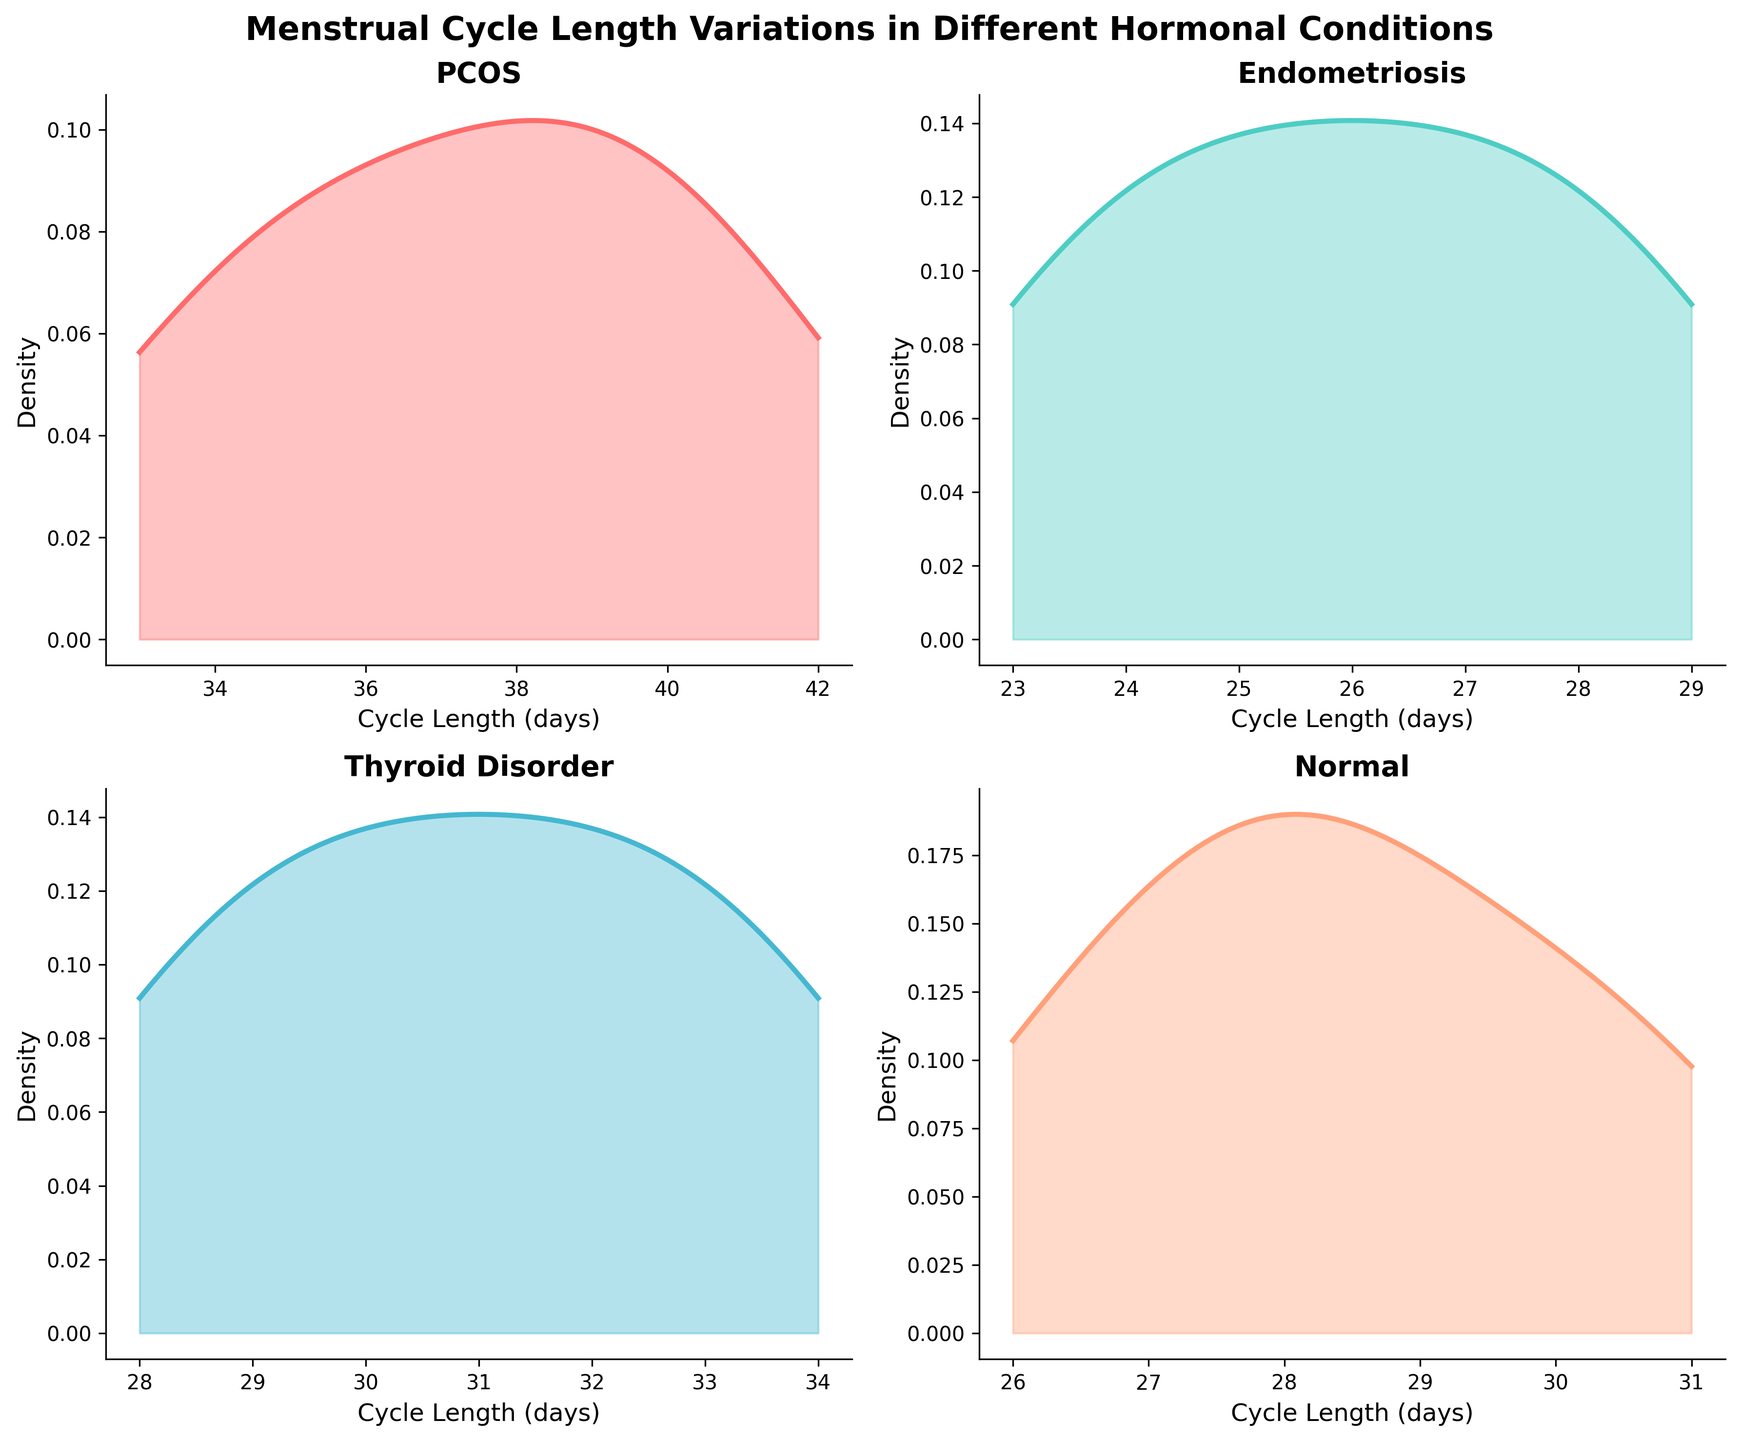How many conditions are presented in the figure? The figure shows four different subplots, each with a unique condition. They are PCOS, Endometriosis, Thyroid Disorder, and Normal, as indicated by the subplot titles.
Answer: 4 Which condition has the highest variability in menstrual cycle length? To determine the condition with the highest variability, observe the spread of the peaks in each subplot. The PCOS subplot shows a wider spread than the other conditions, indicating higher variability in cycle length.
Answer: PCOS What is the range of cycle lengths for the condition with the shortest cycles? By examining the subplots for the condition with the shortest cycles, it appears that Endometriosis has the shortest cycle lengths, ranging approximately from 23 to 29 days.
Answer: 23 to 29 days How do the cycle lengths for women with Thyroid Disorder compare to women with Normal cycle lengths? To compare the two conditions, observe the density plots for Thyroid Disorder and Normal. The cycle lengths for Thyroid Disorder range from 28 to 34 days, while Normal cycle lengths range from 26 to 31 days, indicating a slight shift to longer cycles in Thyroid Disorder.
Answer: Slightly longer in Thyroid Disorder Which two conditions have the most similar density plots? Comparing the shapes and spread of the density plots, Thyroid Disorder and Normal show the most similar distributions, as their cycle lengths overlap significantly in the range and density.
Answer: Thyroid Disorder and Normal What is the most common cycle length for women with PCOS? The peak of the density plot for PCOS indicates the most common cycle length. The highest peak is around 37 days.
Answer: 37 days Are there any conditions where the cycle lengths do not overlap at all? By observing the density plots, PCOS and Endometriosis do not have overlapping cycle lengths. PCOS ranges from about 33 to 42 days, while Endometriosis ranges from 23 to 29 days.
Answer: PCOS and Endometriosis Which condition, if any, has a bimodal distribution? A bimodal distribution would show two distinct peaks. None of the conditions presented exhibits a clearly bimodal distribution; each has a single peak.
Answer: None What is the x-axis label in the subplots? The label for the x-axis in each subplot indicates "Cycle Length (days)". This label is consistent across all the subplots.
Answer: Cycle Length (days) 